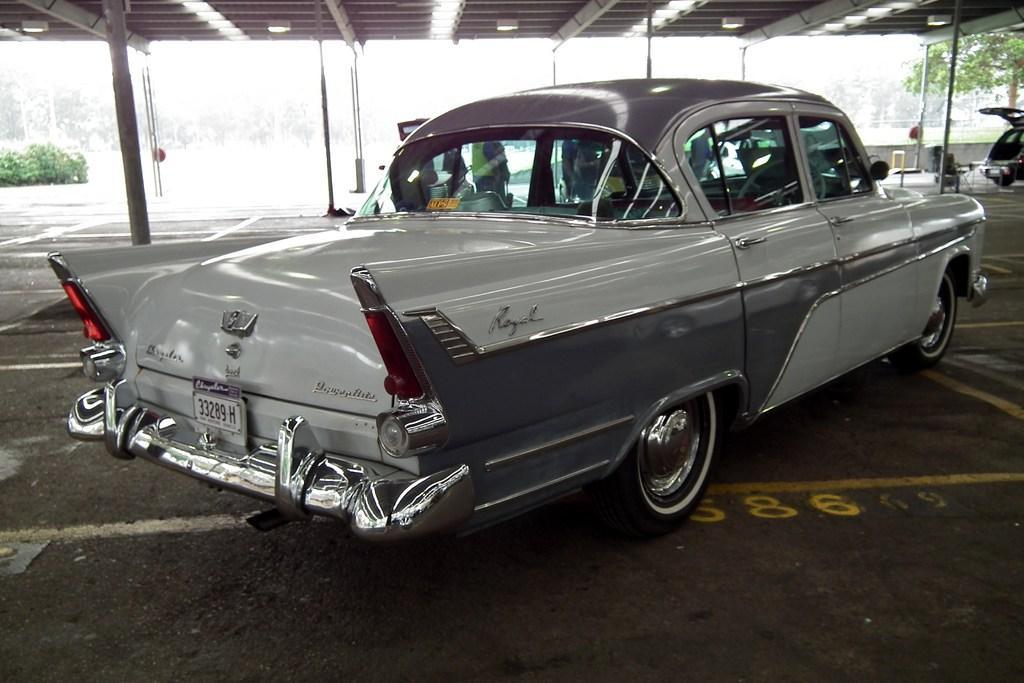Please provide a concise description of this image. In this image in the foreground there is one car, and in the background there are some persons who are standing. And on the top there is ceiling and some wooden poles, in the center and also in the background we could see some plants and some cars. At the bottom there is a floor. 